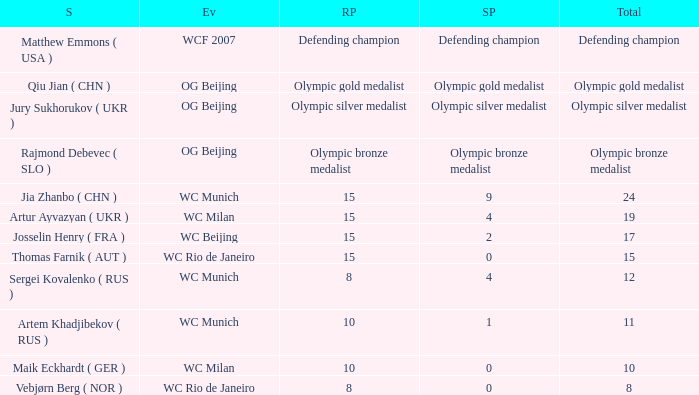Who is the shooter with 15 rank points, and 0 score points? Thomas Farnik ( AUT ). 